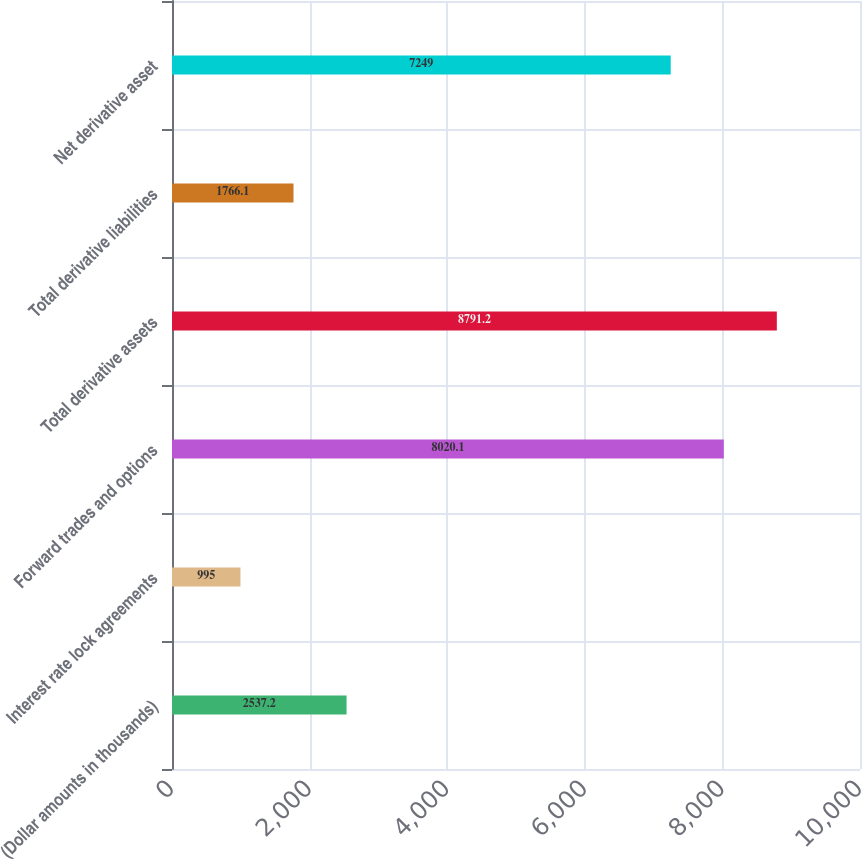Convert chart. <chart><loc_0><loc_0><loc_500><loc_500><bar_chart><fcel>(Dollar amounts in thousands)<fcel>Interest rate lock agreements<fcel>Forward trades and options<fcel>Total derivative assets<fcel>Total derivative liabilities<fcel>Net derivative asset<nl><fcel>2537.2<fcel>995<fcel>8020.1<fcel>8791.2<fcel>1766.1<fcel>7249<nl></chart> 